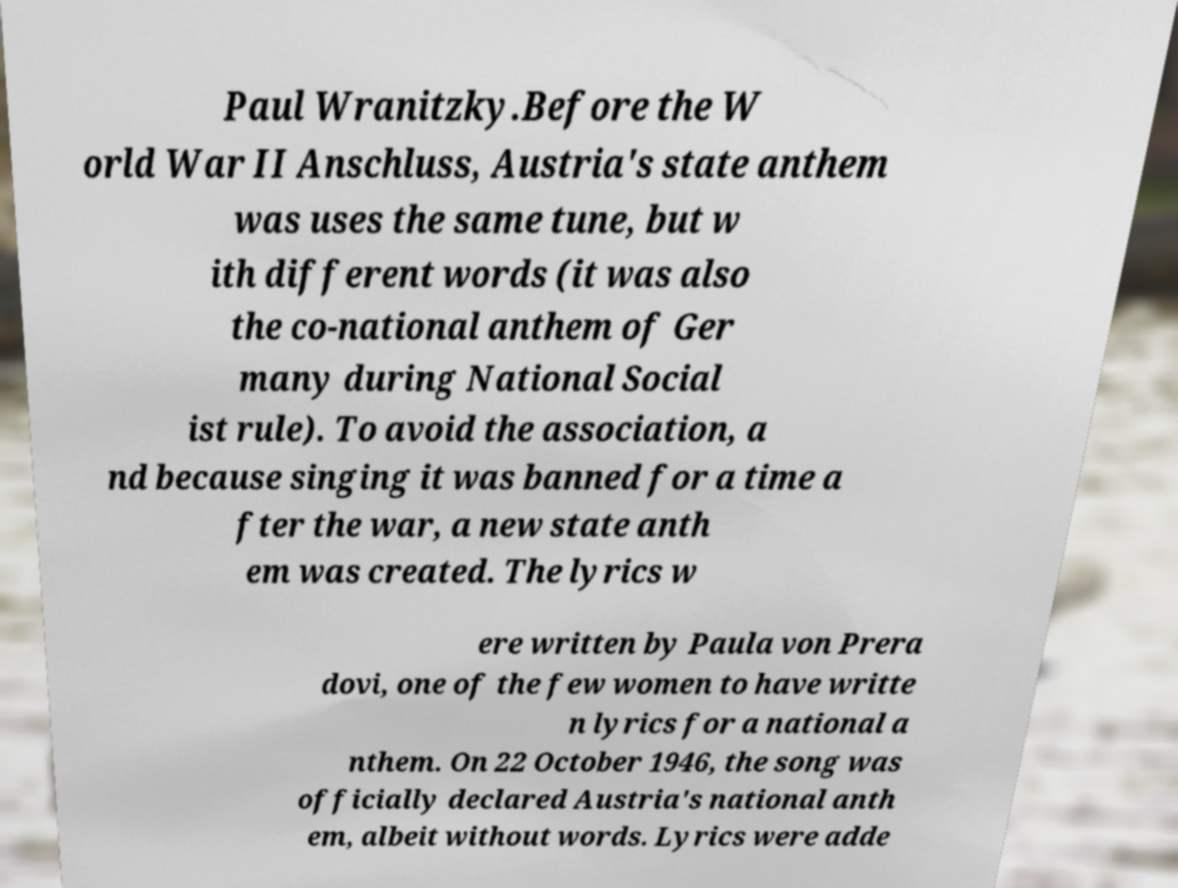I need the written content from this picture converted into text. Can you do that? Paul Wranitzky.Before the W orld War II Anschluss, Austria's state anthem was uses the same tune, but w ith different words (it was also the co-national anthem of Ger many during National Social ist rule). To avoid the association, a nd because singing it was banned for a time a fter the war, a new state anth em was created. The lyrics w ere written by Paula von Prera dovi, one of the few women to have writte n lyrics for a national a nthem. On 22 October 1946, the song was officially declared Austria's national anth em, albeit without words. Lyrics were adde 